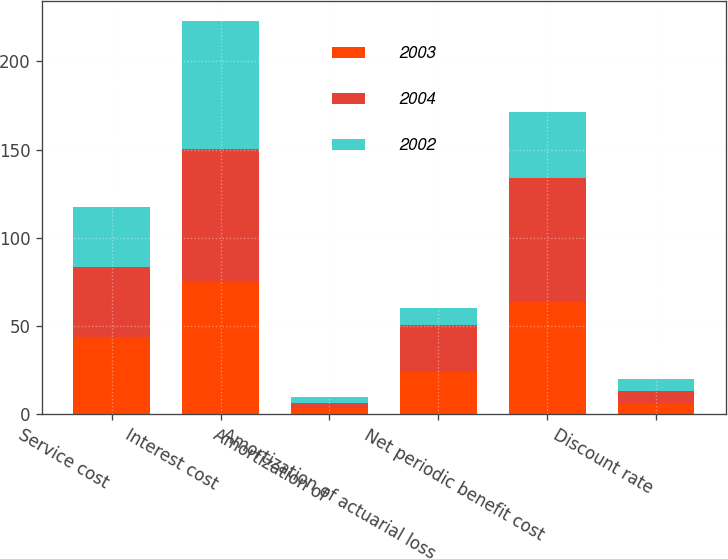Convert chart to OTSL. <chart><loc_0><loc_0><loc_500><loc_500><stacked_bar_chart><ecel><fcel>Service cost<fcel>Interest cost<fcel>Amortization of<fcel>Amortization of actuarial loss<fcel>Net periodic benefit cost<fcel>Discount rate<nl><fcel>2003<fcel>43.8<fcel>75.7<fcel>3.3<fcel>24.2<fcel>63.6<fcel>6.25<nl><fcel>2004<fcel>39.4<fcel>74.5<fcel>3.2<fcel>26.4<fcel>70.3<fcel>6.75<nl><fcel>2002<fcel>34.5<fcel>72.6<fcel>3.1<fcel>9.5<fcel>37.2<fcel>7.25<nl></chart> 